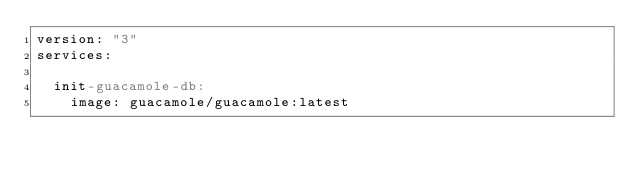Convert code to text. <code><loc_0><loc_0><loc_500><loc_500><_YAML_>version: "3"
services:

  init-guacamole-db:
    image: guacamole/guacamole:latest</code> 